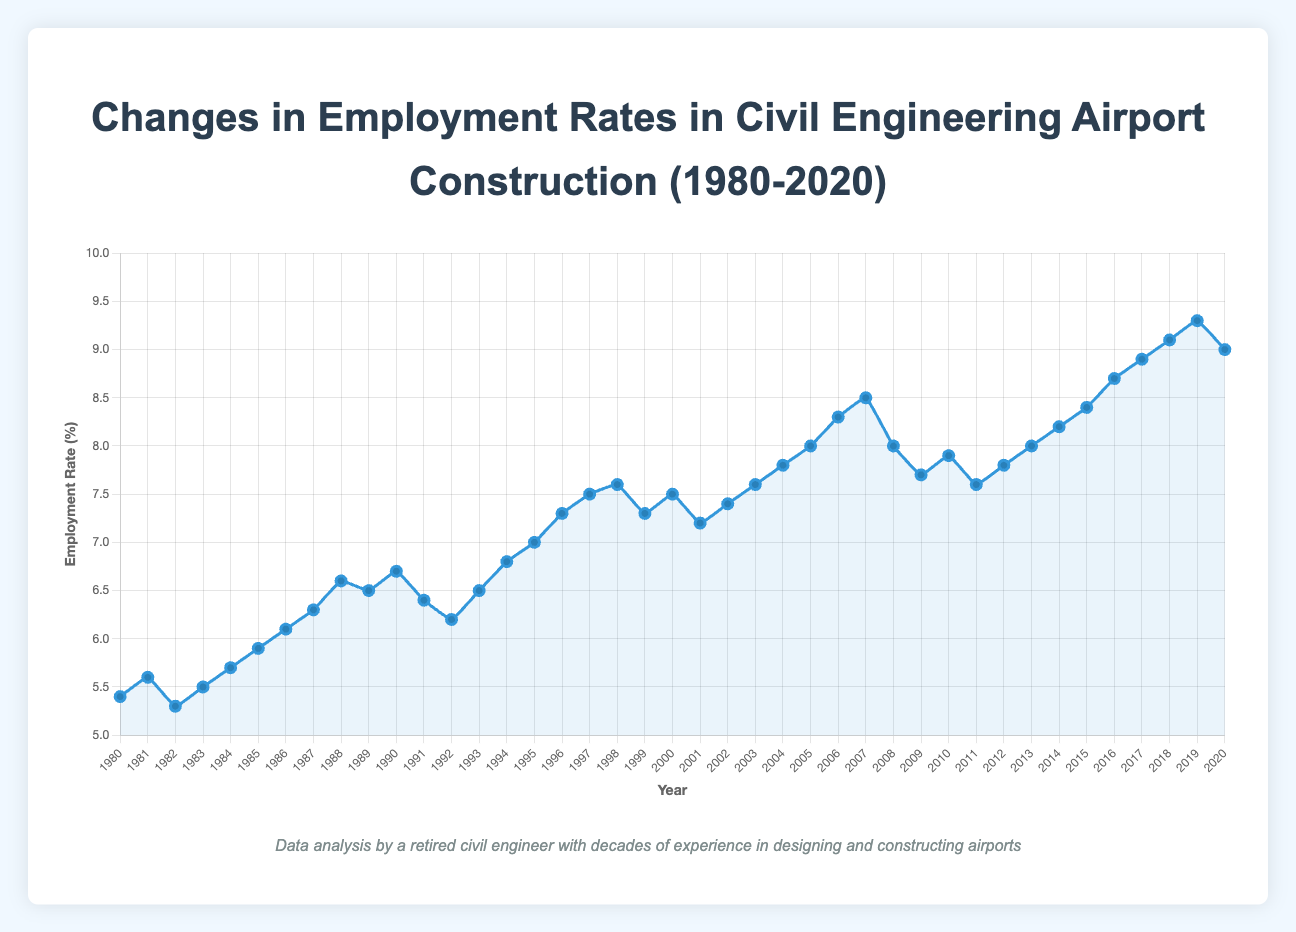What was the employment rate percentage in 1985? The employment rate in 1985 can be directly read from the figure as it is one of the data points on the line chart.
Answer: 5.9 How did the employment rate change from 1980 to 1990? To determine the change, subtract the employment rate in 1980 (5.4%) from the rate in 1990 (6.7%). 6.7 - 5.4 = 1.3%.
Answer: Increased by 1.3% Which year had the highest employment rate percentage, and what was it? To find the year with the highest employment rate, look at all the data points and identify the peak. The highest point is in 2019 with 9.3%.
Answer: 2019, 9.3% Is the employment rate consistent every year between 2000 and 2005? Look at the data points each year from 2000 to 2005. The rates are 7.5%, 7.2%, 7.4%, 7.6%, 7.8%, and 8.0%, showing variation each year.
Answer: No, it varied What is the difference in employment rates between the lowest rate and the highest rate? The lowest rate is 5.3% (1982), and the highest rate is 9.3% (2019). Subtract the lowest rate from the highest. 9.3 - 5.3 = 4%.
Answer: 4% During which decade did the employment rate see the most significant increase? Compare the rate increases for each decade: 1980-1990, 1990-2000, 2000-2010, 2010-2020. The 2010s saw an increase from 7.8% to 9.0%, totaling 1.2%.
Answer: 2010s What was the employment rate trend during the 1990s? By examining the data from 1990 (6.7%) to 1999 (7.3%), the general trend shows an increase over the decade.
Answer: Increasing Between which two consecutive years did the employment rate percentage drop the most? By calculating the differences year by year and identifying the largest decrease, the most significant drop is from 2008 (8.0%) to 2009 (7.7%), a 0.3% decline.
Answer: 2008 to 2009 Was there any year when the employment rate was exactly the same as the previous year? Review the data points year by year to check for identical values. No consecutive years have the same rate.
Answer: No 